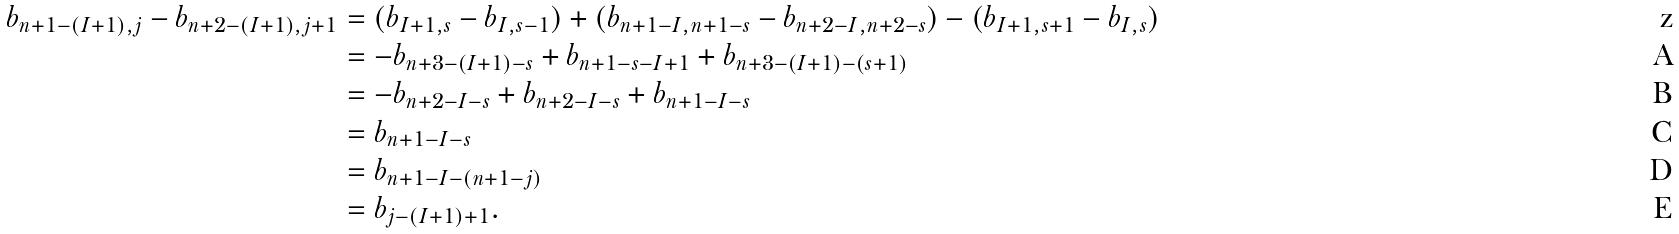Convert formula to latex. <formula><loc_0><loc_0><loc_500><loc_500>b _ { n + 1 - ( I + 1 ) , j } - b _ { n + 2 - ( I + 1 ) , j + 1 } & = ( b _ { I + 1 , s } - b _ { I , s - 1 } ) + ( b _ { n + 1 - I , n + 1 - s } - b _ { n + 2 - I , n + 2 - s } ) - ( b _ { I + 1 , s + 1 } - b _ { I , s } ) \\ & = - b _ { n + 3 - ( I + 1 ) - s } + b _ { n + 1 - s - I + 1 } + b _ { n + 3 - ( I + 1 ) - ( s + 1 ) } \\ & = - b _ { n + 2 - I - s } + b _ { n + 2 - I - s } + b _ { n + 1 - I - s } \\ & = b _ { n + 1 - I - s } \\ & = b _ { n + 1 - I - ( n + 1 - j ) } \\ & = b _ { j - ( I + 1 ) + 1 } .</formula> 